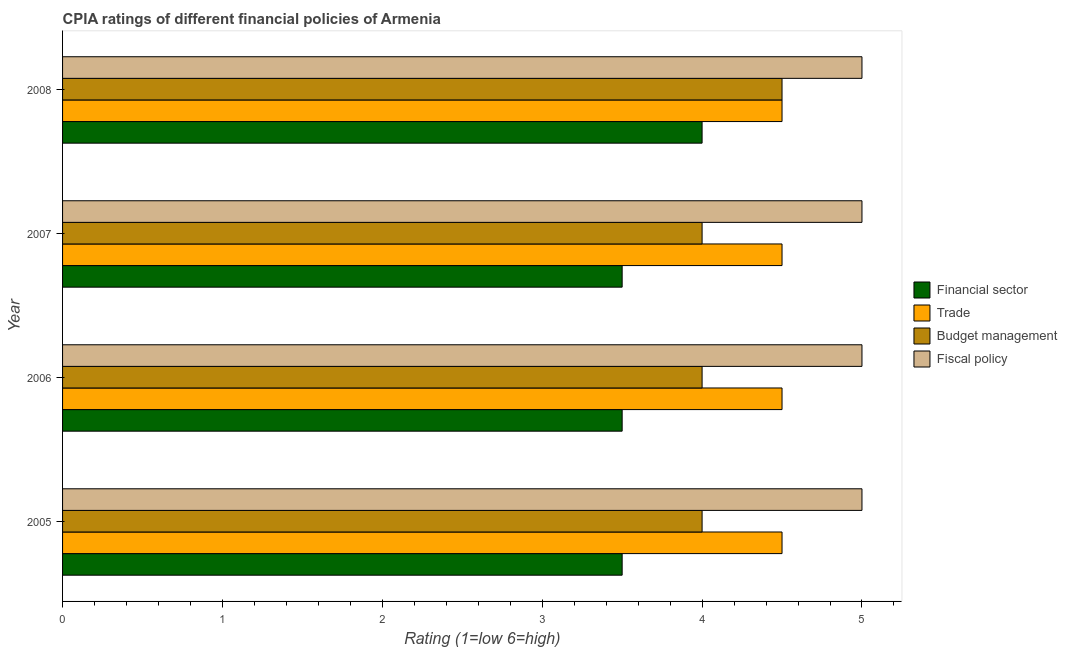How many groups of bars are there?
Your answer should be very brief. 4. How many bars are there on the 3rd tick from the top?
Offer a terse response. 4. What is the label of the 4th group of bars from the top?
Your answer should be very brief. 2005. What is the cpia rating of fiscal policy in 2006?
Make the answer very short. 5. Across all years, what is the maximum cpia rating of trade?
Offer a terse response. 4.5. In which year was the cpia rating of fiscal policy maximum?
Offer a terse response. 2005. What is the difference between the cpia rating of fiscal policy in 2007 and the cpia rating of budget management in 2008?
Ensure brevity in your answer.  0.5. What is the average cpia rating of fiscal policy per year?
Make the answer very short. 5. In the year 2005, what is the difference between the cpia rating of trade and cpia rating of financial sector?
Keep it short and to the point. 1. In how many years, is the cpia rating of financial sector greater than 0.4 ?
Offer a terse response. 4. Is the difference between the cpia rating of budget management in 2005 and 2006 greater than the difference between the cpia rating of financial sector in 2005 and 2006?
Offer a very short reply. No. What is the difference between the highest and the second highest cpia rating of financial sector?
Give a very brief answer. 0.5. In how many years, is the cpia rating of financial sector greater than the average cpia rating of financial sector taken over all years?
Give a very brief answer. 1. Is the sum of the cpia rating of budget management in 2005 and 2008 greater than the maximum cpia rating of fiscal policy across all years?
Keep it short and to the point. Yes. Is it the case that in every year, the sum of the cpia rating of fiscal policy and cpia rating of budget management is greater than the sum of cpia rating of financial sector and cpia rating of trade?
Your answer should be compact. Yes. What does the 3rd bar from the top in 2008 represents?
Your answer should be compact. Trade. What does the 4th bar from the bottom in 2007 represents?
Ensure brevity in your answer.  Fiscal policy. Is it the case that in every year, the sum of the cpia rating of financial sector and cpia rating of trade is greater than the cpia rating of budget management?
Provide a succinct answer. Yes. How many bars are there?
Offer a terse response. 16. Does the graph contain any zero values?
Make the answer very short. No. Where does the legend appear in the graph?
Your response must be concise. Center right. What is the title of the graph?
Offer a terse response. CPIA ratings of different financial policies of Armenia. What is the Rating (1=low 6=high) of Financial sector in 2005?
Provide a succinct answer. 3.5. What is the Rating (1=low 6=high) of Trade in 2005?
Provide a short and direct response. 4.5. What is the Rating (1=low 6=high) in Budget management in 2005?
Offer a terse response. 4. What is the Rating (1=low 6=high) in Trade in 2006?
Ensure brevity in your answer.  4.5. What is the Rating (1=low 6=high) of Financial sector in 2007?
Your answer should be compact. 3.5. What is the Rating (1=low 6=high) in Trade in 2007?
Provide a short and direct response. 4.5. What is the Rating (1=low 6=high) of Budget management in 2008?
Make the answer very short. 4.5. Across all years, what is the maximum Rating (1=low 6=high) in Trade?
Your answer should be very brief. 4.5. Across all years, what is the maximum Rating (1=low 6=high) of Budget management?
Offer a very short reply. 4.5. Across all years, what is the maximum Rating (1=low 6=high) in Fiscal policy?
Your answer should be compact. 5. Across all years, what is the minimum Rating (1=low 6=high) in Trade?
Keep it short and to the point. 4.5. What is the total Rating (1=low 6=high) in Financial sector in the graph?
Your answer should be very brief. 14.5. What is the total Rating (1=low 6=high) in Budget management in the graph?
Make the answer very short. 16.5. What is the total Rating (1=low 6=high) of Fiscal policy in the graph?
Offer a terse response. 20. What is the difference between the Rating (1=low 6=high) in Trade in 2005 and that in 2006?
Offer a very short reply. 0. What is the difference between the Rating (1=low 6=high) of Budget management in 2005 and that in 2006?
Provide a succinct answer. 0. What is the difference between the Rating (1=low 6=high) of Trade in 2005 and that in 2007?
Make the answer very short. 0. What is the difference between the Rating (1=low 6=high) of Budget management in 2005 and that in 2007?
Your response must be concise. 0. What is the difference between the Rating (1=low 6=high) in Fiscal policy in 2005 and that in 2007?
Your answer should be very brief. 0. What is the difference between the Rating (1=low 6=high) in Budget management in 2005 and that in 2008?
Your answer should be compact. -0.5. What is the difference between the Rating (1=low 6=high) of Financial sector in 2006 and that in 2007?
Provide a succinct answer. 0. What is the difference between the Rating (1=low 6=high) in Budget management in 2006 and that in 2007?
Ensure brevity in your answer.  0. What is the difference between the Rating (1=low 6=high) of Trade in 2006 and that in 2008?
Offer a very short reply. 0. What is the difference between the Rating (1=low 6=high) in Budget management in 2006 and that in 2008?
Provide a succinct answer. -0.5. What is the difference between the Rating (1=low 6=high) of Financial sector in 2007 and that in 2008?
Your response must be concise. -0.5. What is the difference between the Rating (1=low 6=high) in Trade in 2007 and that in 2008?
Your answer should be compact. 0. What is the difference between the Rating (1=low 6=high) of Trade in 2005 and the Rating (1=low 6=high) of Fiscal policy in 2006?
Provide a succinct answer. -0.5. What is the difference between the Rating (1=low 6=high) of Budget management in 2005 and the Rating (1=low 6=high) of Fiscal policy in 2006?
Keep it short and to the point. -1. What is the difference between the Rating (1=low 6=high) in Financial sector in 2005 and the Rating (1=low 6=high) in Trade in 2007?
Keep it short and to the point. -1. What is the difference between the Rating (1=low 6=high) of Trade in 2005 and the Rating (1=low 6=high) of Fiscal policy in 2007?
Offer a terse response. -0.5. What is the difference between the Rating (1=low 6=high) in Financial sector in 2005 and the Rating (1=low 6=high) in Trade in 2008?
Your response must be concise. -1. What is the difference between the Rating (1=low 6=high) in Financial sector in 2005 and the Rating (1=low 6=high) in Budget management in 2008?
Keep it short and to the point. -1. What is the difference between the Rating (1=low 6=high) in Financial sector in 2005 and the Rating (1=low 6=high) in Fiscal policy in 2008?
Give a very brief answer. -1.5. What is the difference between the Rating (1=low 6=high) of Trade in 2005 and the Rating (1=low 6=high) of Budget management in 2008?
Offer a very short reply. 0. What is the difference between the Rating (1=low 6=high) of Trade in 2005 and the Rating (1=low 6=high) of Fiscal policy in 2008?
Your answer should be compact. -0.5. What is the difference between the Rating (1=low 6=high) of Budget management in 2005 and the Rating (1=low 6=high) of Fiscal policy in 2008?
Make the answer very short. -1. What is the difference between the Rating (1=low 6=high) of Financial sector in 2006 and the Rating (1=low 6=high) of Trade in 2007?
Your answer should be very brief. -1. What is the difference between the Rating (1=low 6=high) in Financial sector in 2006 and the Rating (1=low 6=high) in Fiscal policy in 2007?
Offer a terse response. -1.5. What is the difference between the Rating (1=low 6=high) in Trade in 2006 and the Rating (1=low 6=high) in Budget management in 2007?
Offer a terse response. 0.5. What is the difference between the Rating (1=low 6=high) in Trade in 2006 and the Rating (1=low 6=high) in Fiscal policy in 2007?
Ensure brevity in your answer.  -0.5. What is the difference between the Rating (1=low 6=high) in Financial sector in 2006 and the Rating (1=low 6=high) in Trade in 2008?
Your answer should be compact. -1. What is the difference between the Rating (1=low 6=high) in Trade in 2006 and the Rating (1=low 6=high) in Budget management in 2008?
Your answer should be very brief. 0. What is the difference between the Rating (1=low 6=high) in Trade in 2006 and the Rating (1=low 6=high) in Fiscal policy in 2008?
Offer a terse response. -0.5. What is the difference between the Rating (1=low 6=high) in Budget management in 2006 and the Rating (1=low 6=high) in Fiscal policy in 2008?
Offer a very short reply. -1. What is the difference between the Rating (1=low 6=high) in Financial sector in 2007 and the Rating (1=low 6=high) in Budget management in 2008?
Make the answer very short. -1. What is the difference between the Rating (1=low 6=high) of Financial sector in 2007 and the Rating (1=low 6=high) of Fiscal policy in 2008?
Your answer should be very brief. -1.5. What is the difference between the Rating (1=low 6=high) of Trade in 2007 and the Rating (1=low 6=high) of Budget management in 2008?
Keep it short and to the point. 0. What is the average Rating (1=low 6=high) of Financial sector per year?
Ensure brevity in your answer.  3.62. What is the average Rating (1=low 6=high) in Budget management per year?
Give a very brief answer. 4.12. What is the average Rating (1=low 6=high) of Fiscal policy per year?
Give a very brief answer. 5. In the year 2005, what is the difference between the Rating (1=low 6=high) in Financial sector and Rating (1=low 6=high) in Budget management?
Make the answer very short. -0.5. In the year 2005, what is the difference between the Rating (1=low 6=high) in Trade and Rating (1=low 6=high) in Fiscal policy?
Offer a terse response. -0.5. In the year 2005, what is the difference between the Rating (1=low 6=high) of Budget management and Rating (1=low 6=high) of Fiscal policy?
Offer a terse response. -1. In the year 2006, what is the difference between the Rating (1=low 6=high) in Financial sector and Rating (1=low 6=high) in Fiscal policy?
Keep it short and to the point. -1.5. In the year 2006, what is the difference between the Rating (1=low 6=high) of Trade and Rating (1=low 6=high) of Budget management?
Your response must be concise. 0.5. In the year 2006, what is the difference between the Rating (1=low 6=high) in Budget management and Rating (1=low 6=high) in Fiscal policy?
Your answer should be compact. -1. In the year 2007, what is the difference between the Rating (1=low 6=high) of Financial sector and Rating (1=low 6=high) of Budget management?
Provide a succinct answer. -0.5. In the year 2007, what is the difference between the Rating (1=low 6=high) of Financial sector and Rating (1=low 6=high) of Fiscal policy?
Make the answer very short. -1.5. In the year 2007, what is the difference between the Rating (1=low 6=high) in Trade and Rating (1=low 6=high) in Fiscal policy?
Your answer should be very brief. -0.5. In the year 2008, what is the difference between the Rating (1=low 6=high) of Financial sector and Rating (1=low 6=high) of Trade?
Give a very brief answer. -0.5. In the year 2008, what is the difference between the Rating (1=low 6=high) of Financial sector and Rating (1=low 6=high) of Budget management?
Keep it short and to the point. -0.5. In the year 2008, what is the difference between the Rating (1=low 6=high) of Trade and Rating (1=low 6=high) of Fiscal policy?
Ensure brevity in your answer.  -0.5. What is the ratio of the Rating (1=low 6=high) in Trade in 2005 to that in 2006?
Make the answer very short. 1. What is the ratio of the Rating (1=low 6=high) in Budget management in 2005 to that in 2006?
Give a very brief answer. 1. What is the ratio of the Rating (1=low 6=high) of Financial sector in 2005 to that in 2007?
Make the answer very short. 1. What is the ratio of the Rating (1=low 6=high) in Fiscal policy in 2005 to that in 2007?
Give a very brief answer. 1. What is the ratio of the Rating (1=low 6=high) in Budget management in 2005 to that in 2008?
Your answer should be very brief. 0.89. What is the ratio of the Rating (1=low 6=high) in Financial sector in 2006 to that in 2007?
Keep it short and to the point. 1. What is the ratio of the Rating (1=low 6=high) of Fiscal policy in 2006 to that in 2008?
Your answer should be compact. 1. What is the ratio of the Rating (1=low 6=high) of Budget management in 2007 to that in 2008?
Your answer should be very brief. 0.89. What is the difference between the highest and the second highest Rating (1=low 6=high) in Financial sector?
Give a very brief answer. 0.5. What is the difference between the highest and the second highest Rating (1=low 6=high) in Fiscal policy?
Keep it short and to the point. 0. What is the difference between the highest and the lowest Rating (1=low 6=high) in Financial sector?
Your answer should be very brief. 0.5. 